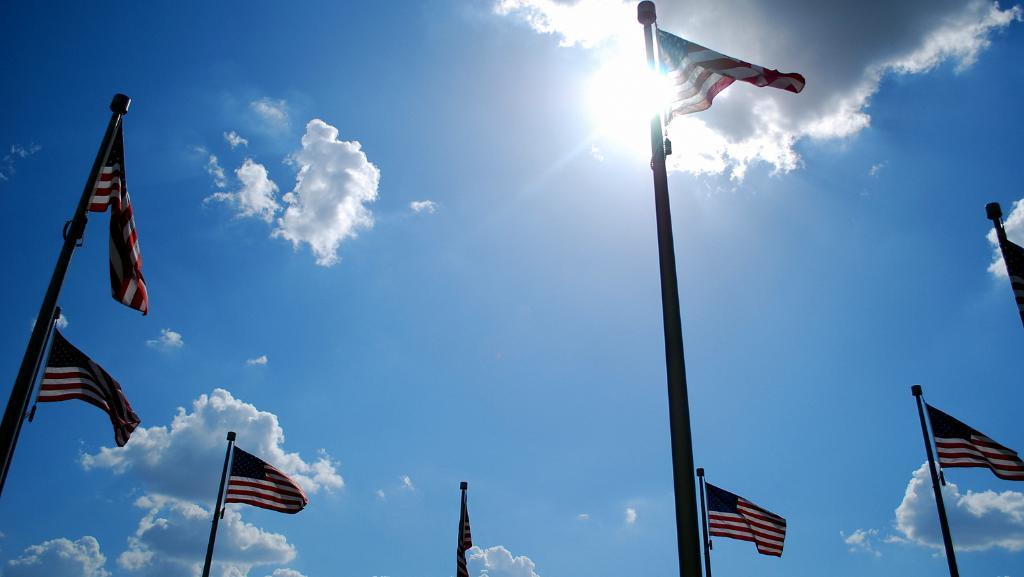What can be seen in the sky in the image? The sky is visible in the image, and the sun is also visible. What else is present in the sky besides the sun? There are clouds in the image. What type of objects are present in the image that are made of metal? There are multiple iron metal poles in the image. What is attached to the metal poles? Flags and lights are present on the metal poles. What type of calendar is hanging on the metal poles in the image? There is no calendar present in the image; it features metal poles with flags and lights. What is the stem of the sun in the image? The sun in the image does not have a stem; it is a celestial body. 